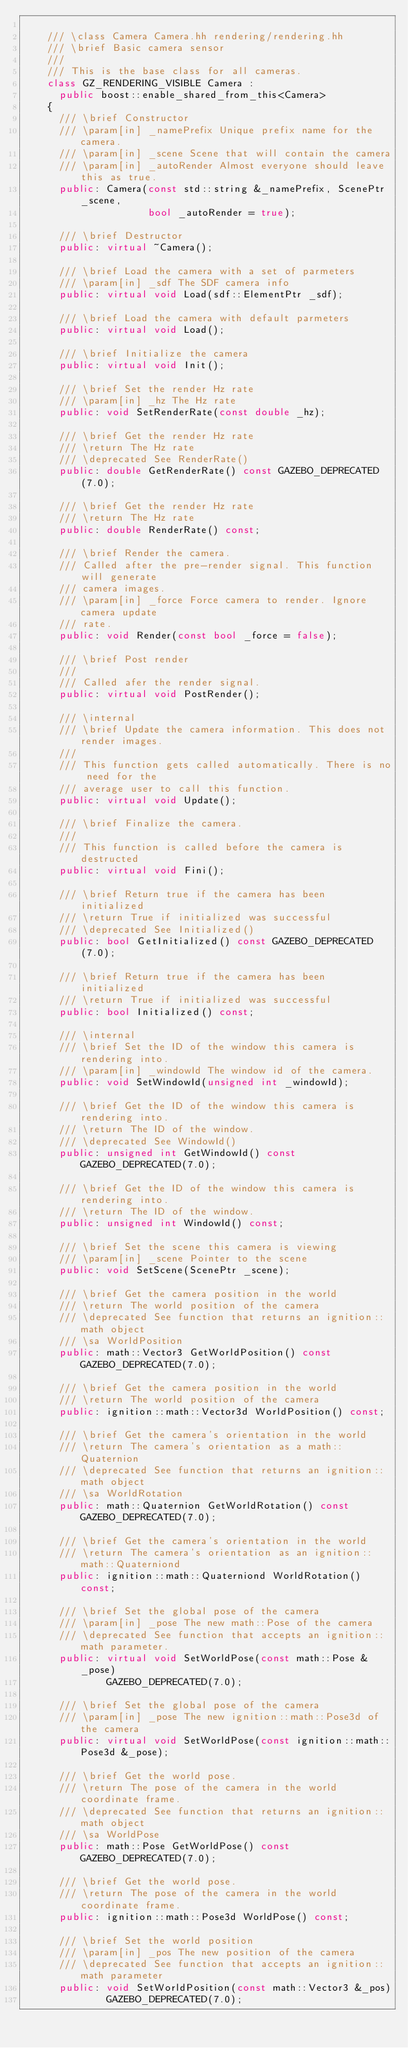<code> <loc_0><loc_0><loc_500><loc_500><_C++_>
    /// \class Camera Camera.hh rendering/rendering.hh
    /// \brief Basic camera sensor
    ///
    /// This is the base class for all cameras.
    class GZ_RENDERING_VISIBLE Camera :
      public boost::enable_shared_from_this<Camera>
    {
      /// \brief Constructor
      /// \param[in] _namePrefix Unique prefix name for the camera.
      /// \param[in] _scene Scene that will contain the camera
      /// \param[in] _autoRender Almost everyone should leave this as true.
      public: Camera(const std::string &_namePrefix, ScenePtr _scene,
                     bool _autoRender = true);

      /// \brief Destructor
      public: virtual ~Camera();

      /// \brief Load the camera with a set of parmeters
      /// \param[in] _sdf The SDF camera info
      public: virtual void Load(sdf::ElementPtr _sdf);

      /// \brief Load the camera with default parmeters
      public: virtual void Load();

      /// \brief Initialize the camera
      public: virtual void Init();

      /// \brief Set the render Hz rate
      /// \param[in] _hz The Hz rate
      public: void SetRenderRate(const double _hz);

      /// \brief Get the render Hz rate
      /// \return The Hz rate
      /// \deprecated See RenderRate()
      public: double GetRenderRate() const GAZEBO_DEPRECATED(7.0);

      /// \brief Get the render Hz rate
      /// \return The Hz rate
      public: double RenderRate() const;

      /// \brief Render the camera.
      /// Called after the pre-render signal. This function will generate
      /// camera images.
      /// \param[in] _force Force camera to render. Ignore camera update
      /// rate.
      public: void Render(const bool _force = false);

      /// \brief Post render
      ///
      /// Called afer the render signal.
      public: virtual void PostRender();

      /// \internal
      /// \brief Update the camera information. This does not render images.
      ///
      /// This function gets called automatically. There is no need for the
      /// average user to call this function.
      public: virtual void Update();

      /// \brief Finalize the camera.
      ///
      /// This function is called before the camera is destructed
      public: virtual void Fini();

      /// \brief Return true if the camera has been initialized
      /// \return True if initialized was successful
      /// \deprecated See Initialized()
      public: bool GetInitialized() const GAZEBO_DEPRECATED(7.0);

      /// \brief Return true if the camera has been initialized
      /// \return True if initialized was successful
      public: bool Initialized() const;

      /// \internal
      /// \brief Set the ID of the window this camera is rendering into.
      /// \param[in] _windowId The window id of the camera.
      public: void SetWindowId(unsigned int _windowId);

      /// \brief Get the ID of the window this camera is rendering into.
      /// \return The ID of the window.
      /// \deprecated See WindowId()
      public: unsigned int GetWindowId() const GAZEBO_DEPRECATED(7.0);

      /// \brief Get the ID of the window this camera is rendering into.
      /// \return The ID of the window.
      public: unsigned int WindowId() const;

      /// \brief Set the scene this camera is viewing
      /// \param[in] _scene Pointer to the scene
      public: void SetScene(ScenePtr _scene);

      /// \brief Get the camera position in the world
      /// \return The world position of the camera
      /// \deprecated See function that returns an ignition::math object
      /// \sa WorldPosition
      public: math::Vector3 GetWorldPosition() const GAZEBO_DEPRECATED(7.0);

      /// \brief Get the camera position in the world
      /// \return The world position of the camera
      public: ignition::math::Vector3d WorldPosition() const;

      /// \brief Get the camera's orientation in the world
      /// \return The camera's orientation as a math::Quaternion
      /// \deprecated See function that returns an ignition::math object
      /// \sa WorldRotation
      public: math::Quaternion GetWorldRotation() const GAZEBO_DEPRECATED(7.0);

      /// \brief Get the camera's orientation in the world
      /// \return The camera's orientation as an ignition::math::Quaterniond
      public: ignition::math::Quaterniond WorldRotation() const;

      /// \brief Set the global pose of the camera
      /// \param[in] _pose The new math::Pose of the camera
      /// \deprecated See function that accepts an ignition::math parameter.
      public: virtual void SetWorldPose(const math::Pose &_pose)
              GAZEBO_DEPRECATED(7.0);

      /// \brief Set the global pose of the camera
      /// \param[in] _pose The new ignition::math::Pose3d of the camera
      public: virtual void SetWorldPose(const ignition::math::Pose3d &_pose);

      /// \brief Get the world pose.
      /// \return The pose of the camera in the world coordinate frame.
      /// \deprecated See function that returns an ignition::math object
      /// \sa WorldPose
      public: math::Pose GetWorldPose() const GAZEBO_DEPRECATED(7.0);

      /// \brief Get the world pose.
      /// \return The pose of the camera in the world coordinate frame.
      public: ignition::math::Pose3d WorldPose() const;

      /// \brief Set the world position
      /// \param[in] _pos The new position of the camera
      /// \deprecated See function that accepts an ignition::math parameter
      public: void SetWorldPosition(const math::Vector3 &_pos)
              GAZEBO_DEPRECATED(7.0);
</code> 